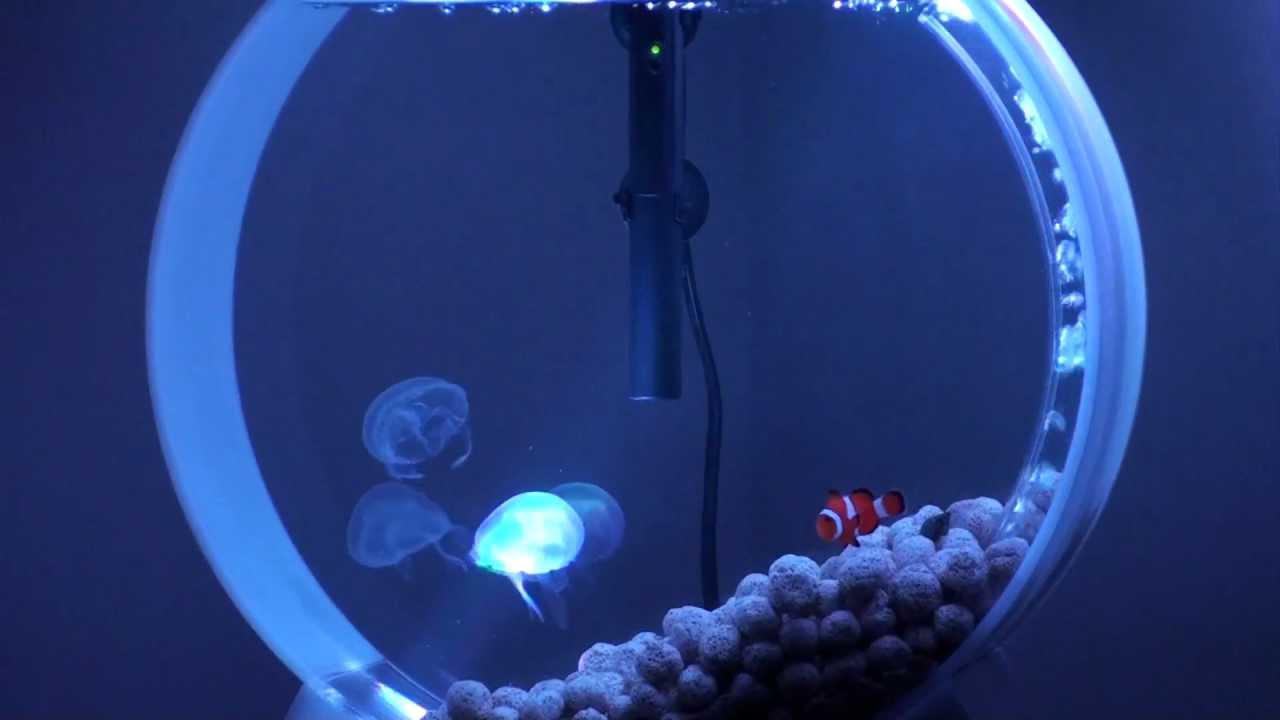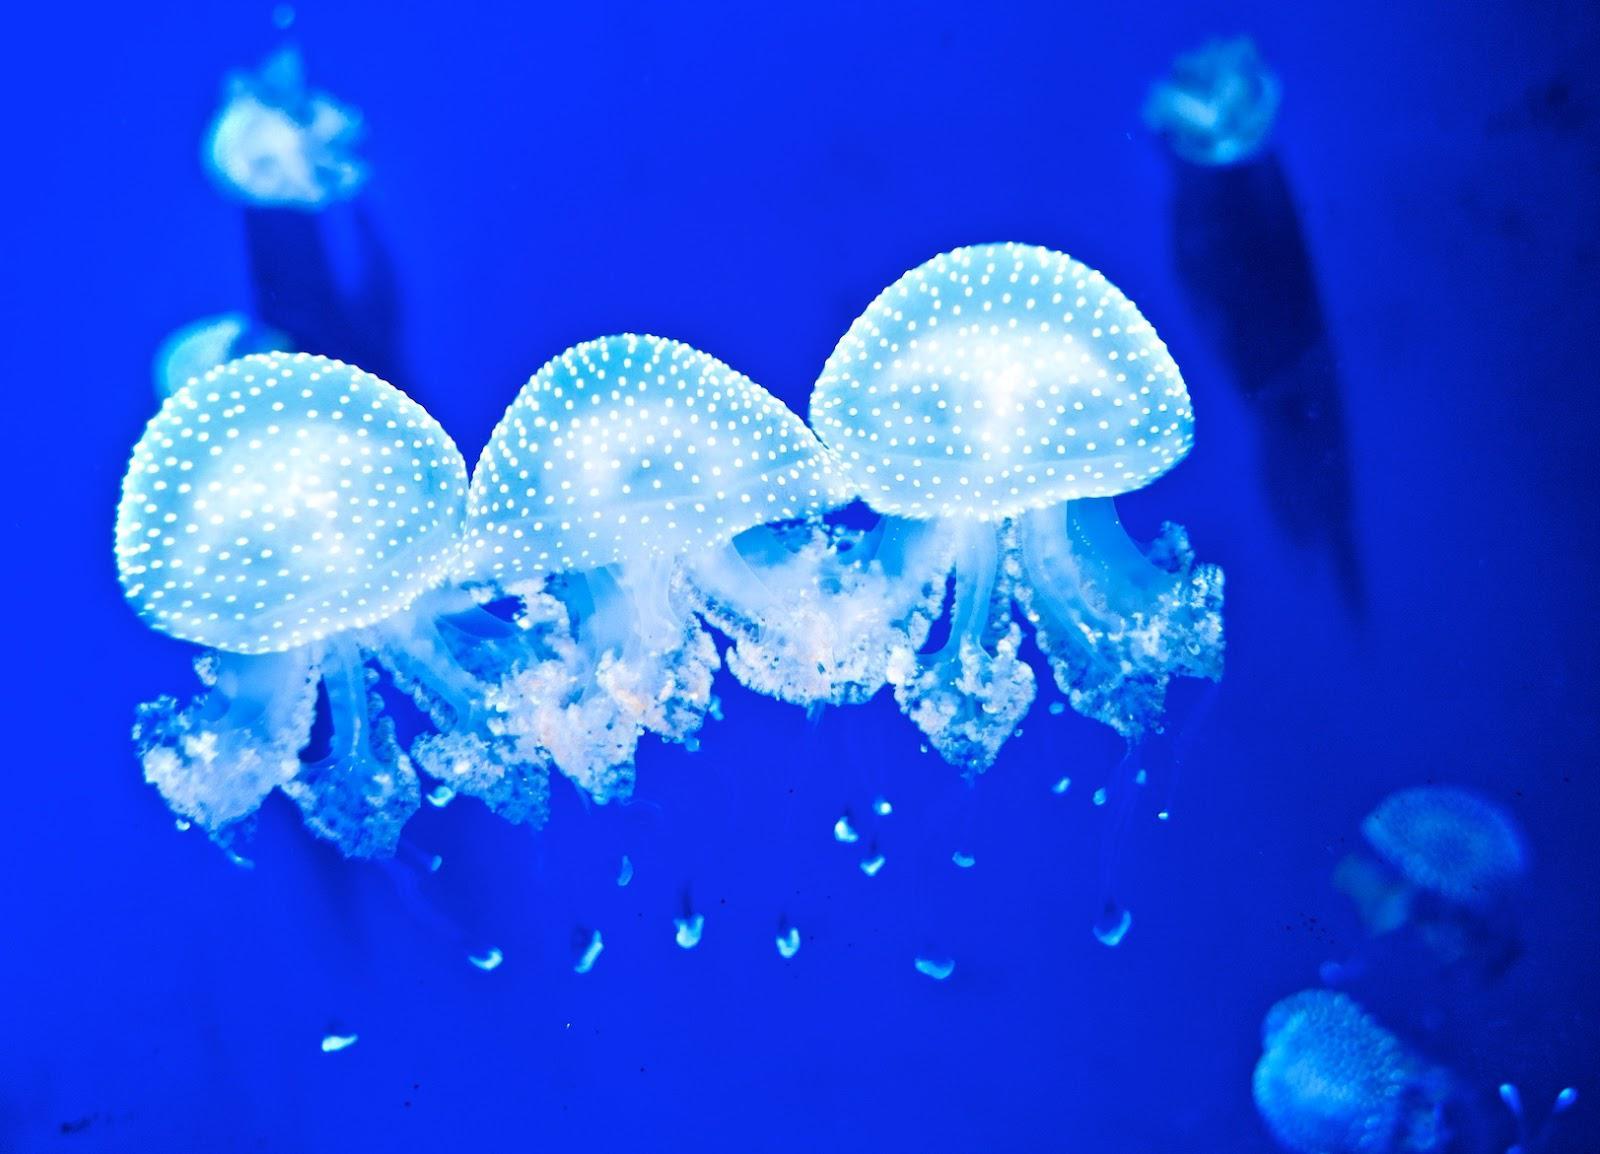The first image is the image on the left, the second image is the image on the right. Examine the images to the left and right. Is the description "Some jellyfish are traveling downwards." accurate? Answer yes or no. No. The first image is the image on the left, the second image is the image on the right. Examine the images to the left and right. Is the description "Foreground of the right image shows exactly two polka-dotted mushroom-shaped jellyfish with frilly tendrils." accurate? Answer yes or no. No. 